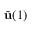<formula> <loc_0><loc_0><loc_500><loc_500>\tilde { u } ( 1 )</formula> 